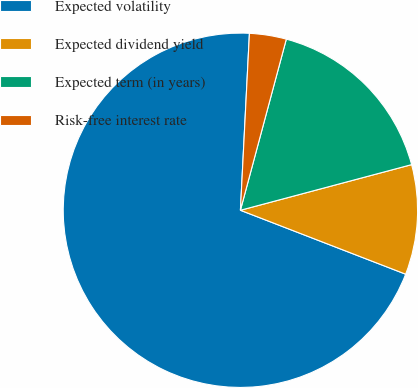Convert chart to OTSL. <chart><loc_0><loc_0><loc_500><loc_500><pie_chart><fcel>Expected volatility<fcel>Expected dividend yield<fcel>Expected term (in years)<fcel>Risk-free interest rate<nl><fcel>69.93%<fcel>10.02%<fcel>16.68%<fcel>3.36%<nl></chart> 